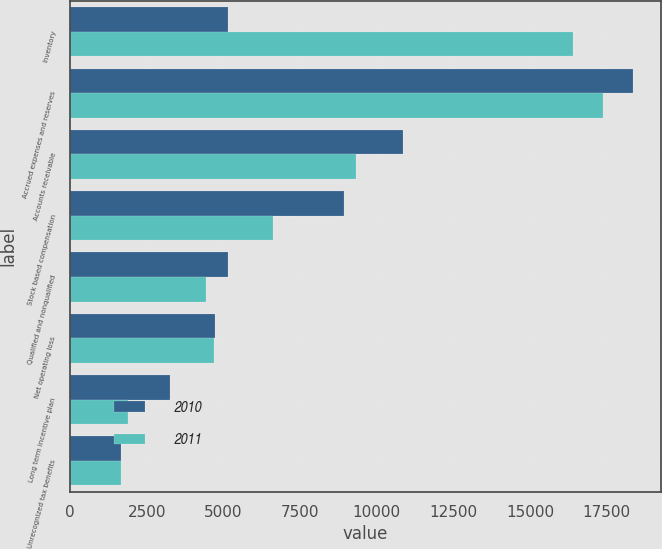Convert chart to OTSL. <chart><loc_0><loc_0><loc_500><loc_500><stacked_bar_chart><ecel><fcel>Inventory<fcel>Accrued expenses and reserves<fcel>Accounts receivable<fcel>Stock based compensation<fcel>Qualified and nonqualified<fcel>Net operating loss<fcel>Long term incentive plan<fcel>Unrecognized tax benefits<nl><fcel>2010<fcel>5157<fcel>18357<fcel>10860<fcel>8945<fcel>5157<fcel>4722<fcel>3260<fcel>1669<nl><fcel>2011<fcel>16409<fcel>17379<fcel>9330<fcel>6609<fcel>4422<fcel>4681<fcel>1889<fcel>1657<nl></chart> 